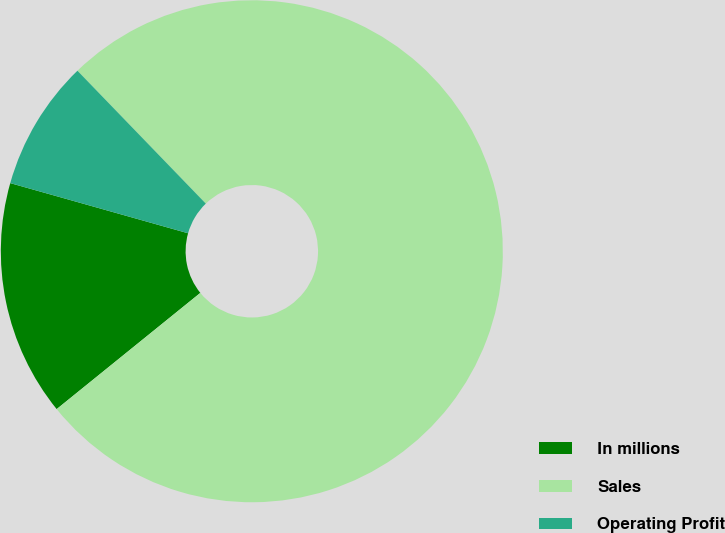Convert chart to OTSL. <chart><loc_0><loc_0><loc_500><loc_500><pie_chart><fcel>In millions<fcel>Sales<fcel>Operating Profit<nl><fcel>15.2%<fcel>76.4%<fcel>8.4%<nl></chart> 